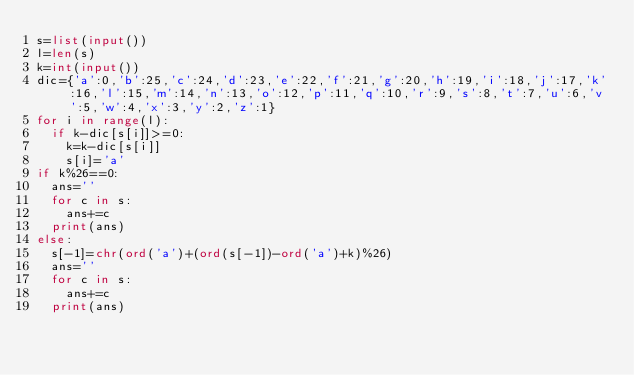Convert code to text. <code><loc_0><loc_0><loc_500><loc_500><_Python_>s=list(input())
l=len(s)
k=int(input())
dic={'a':0,'b':25,'c':24,'d':23,'e':22,'f':21,'g':20,'h':19,'i':18,'j':17,'k':16,'l':15,'m':14,'n':13,'o':12,'p':11,'q':10,'r':9,'s':8,'t':7,'u':6,'v':5,'w':4,'x':3,'y':2,'z':1}
for i in range(l):
  if k-dic[s[i]]>=0:
    k=k-dic[s[i]]
    s[i]='a'
if k%26==0:
  ans=''
  for c in s:
    ans+=c
  print(ans)
else:
  s[-1]=chr(ord('a')+(ord(s[-1])-ord('a')+k)%26)
  ans=''
  for c in s:
    ans+=c
  print(ans)</code> 